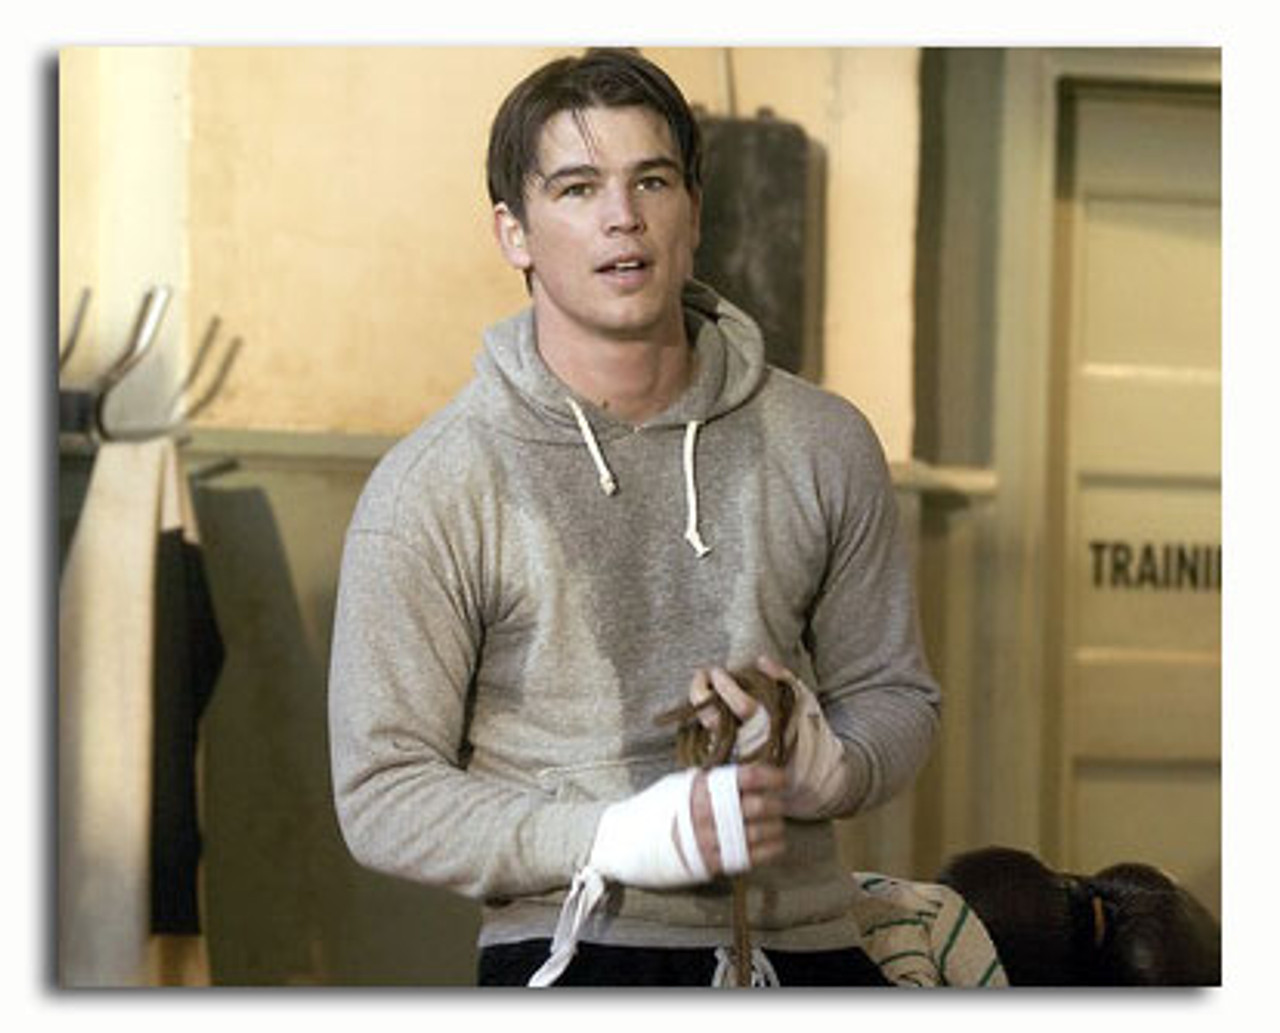What might be the significance of the bandages seen on the person's wrists? The bandages around the person's wrists are typically used in boxing to stabilize the wrist joints, preventing injuries such as sprains. They also help cushion the impact when hitting heavy bags or sparring partners, providing extra support and protection during practice or bouts. 